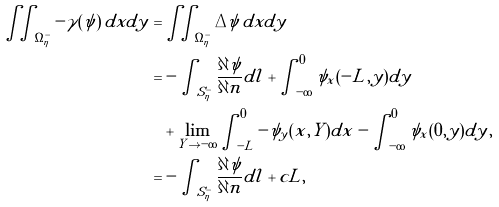<formula> <loc_0><loc_0><loc_500><loc_500>\iint _ { \Omega ^ { - } _ { \eta } } - \gamma ( \psi ) \, d x d y = & \iint _ { \Omega ^ { - } _ { \eta } } \Delta \psi \, d x d y \\ = & - \int _ { S ^ { - } _ { \eta } } \frac { \partial \psi } { \partial n } d l + \int ^ { 0 } _ { - \infty } \psi _ { x } ( - L , y ) d y \\ & + \lim _ { Y \to - \infty } \int ^ { 0 } _ { - L } - \psi _ { y } ( x , Y ) d x - \int ^ { 0 } _ { - \infty } \psi _ { x } ( 0 , y ) d y , \\ = & - \int _ { S ^ { - } _ { \eta } } \frac { \partial \psi } { \partial n } d l + c L ,</formula> 